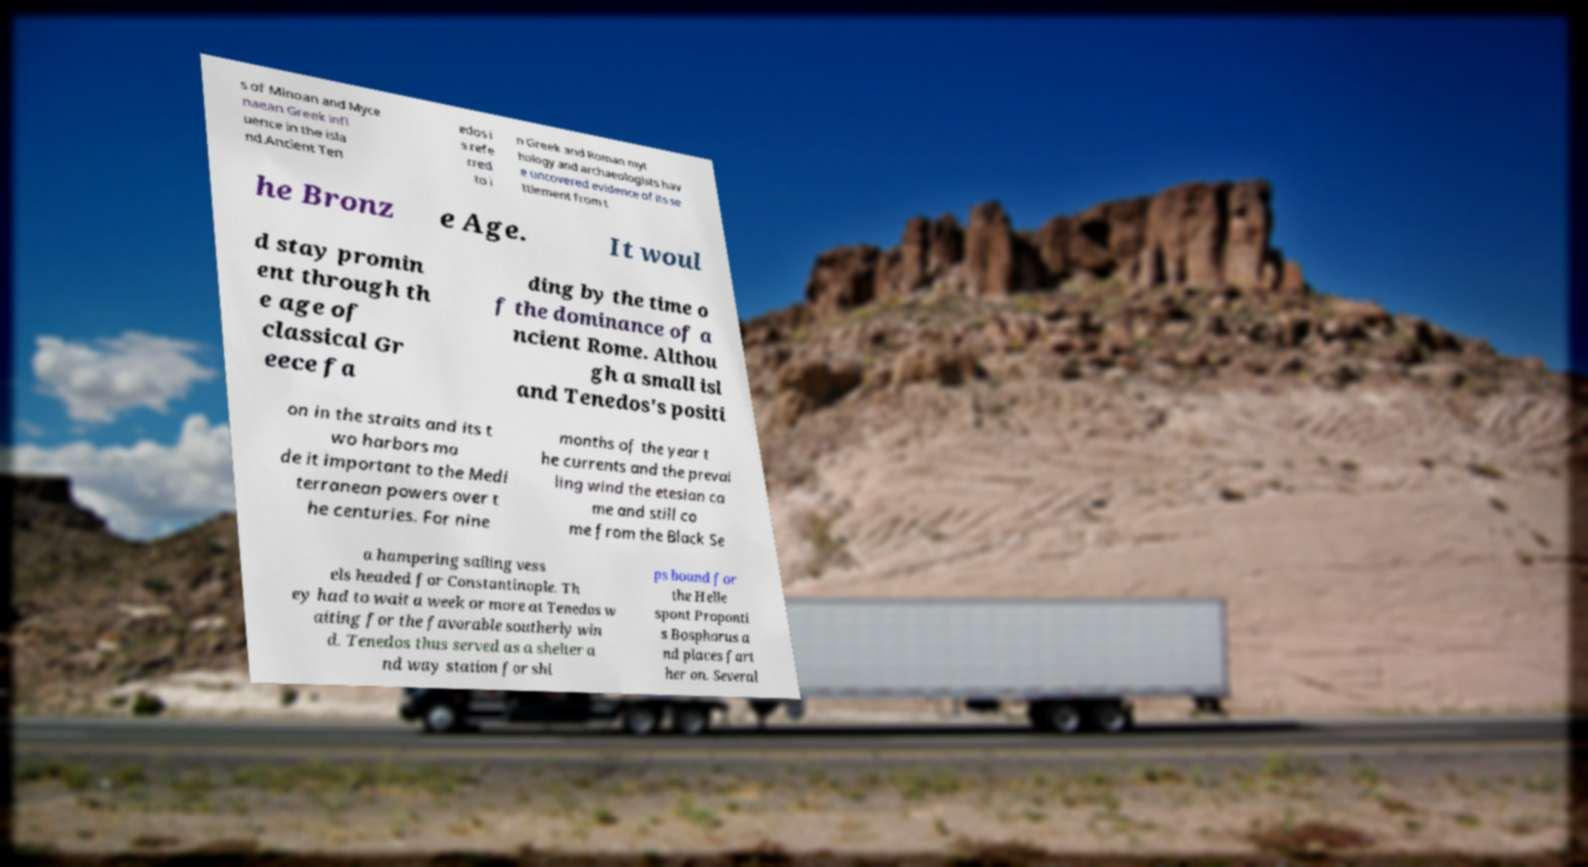What messages or text are displayed in this image? I need them in a readable, typed format. s of Minoan and Myce naean Greek infl uence in the isla nd.Ancient Ten edos i s refe rred to i n Greek and Roman myt hology and archaeologists hav e uncovered evidence of its se ttlement from t he Bronz e Age. It woul d stay promin ent through th e age of classical Gr eece fa ding by the time o f the dominance of a ncient Rome. Althou gh a small isl and Tenedos's positi on in the straits and its t wo harbors ma de it important to the Medi terranean powers over t he centuries. For nine months of the year t he currents and the prevai ling wind the etesian ca me and still co me from the Black Se a hampering sailing vess els headed for Constantinople. Th ey had to wait a week or more at Tenedos w aiting for the favorable southerly win d. Tenedos thus served as a shelter a nd way station for shi ps bound for the Helle spont Proponti s Bosphorus a nd places fart her on. Several 